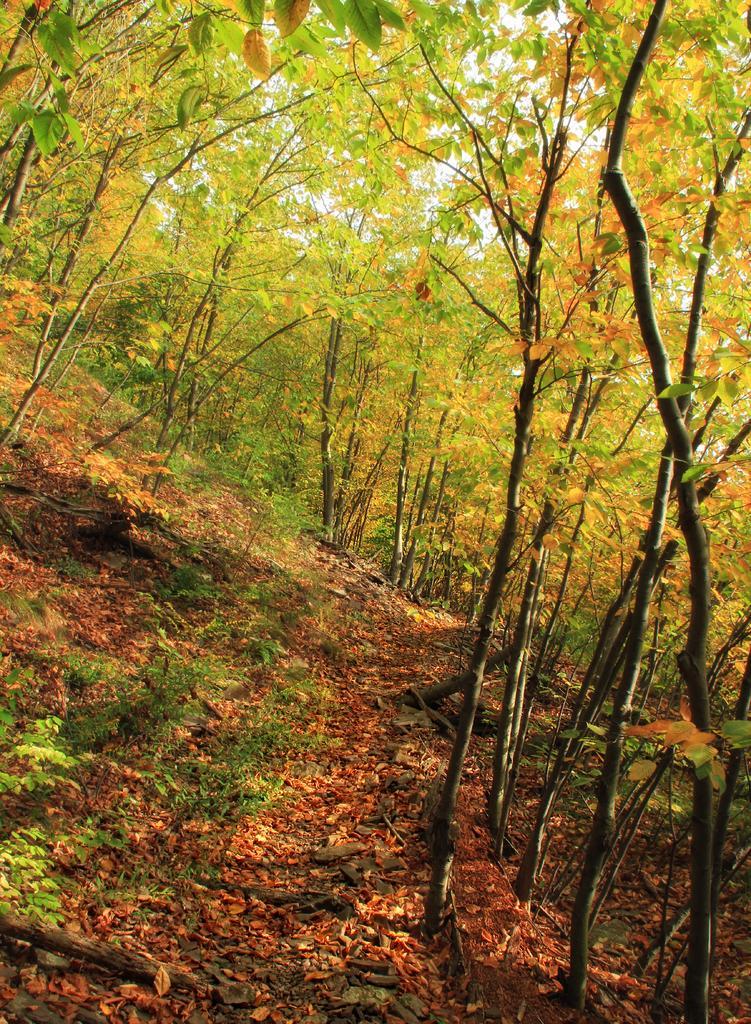Could you give a brief overview of what you see in this image? In this picture I can see plants, leaves and trees. 